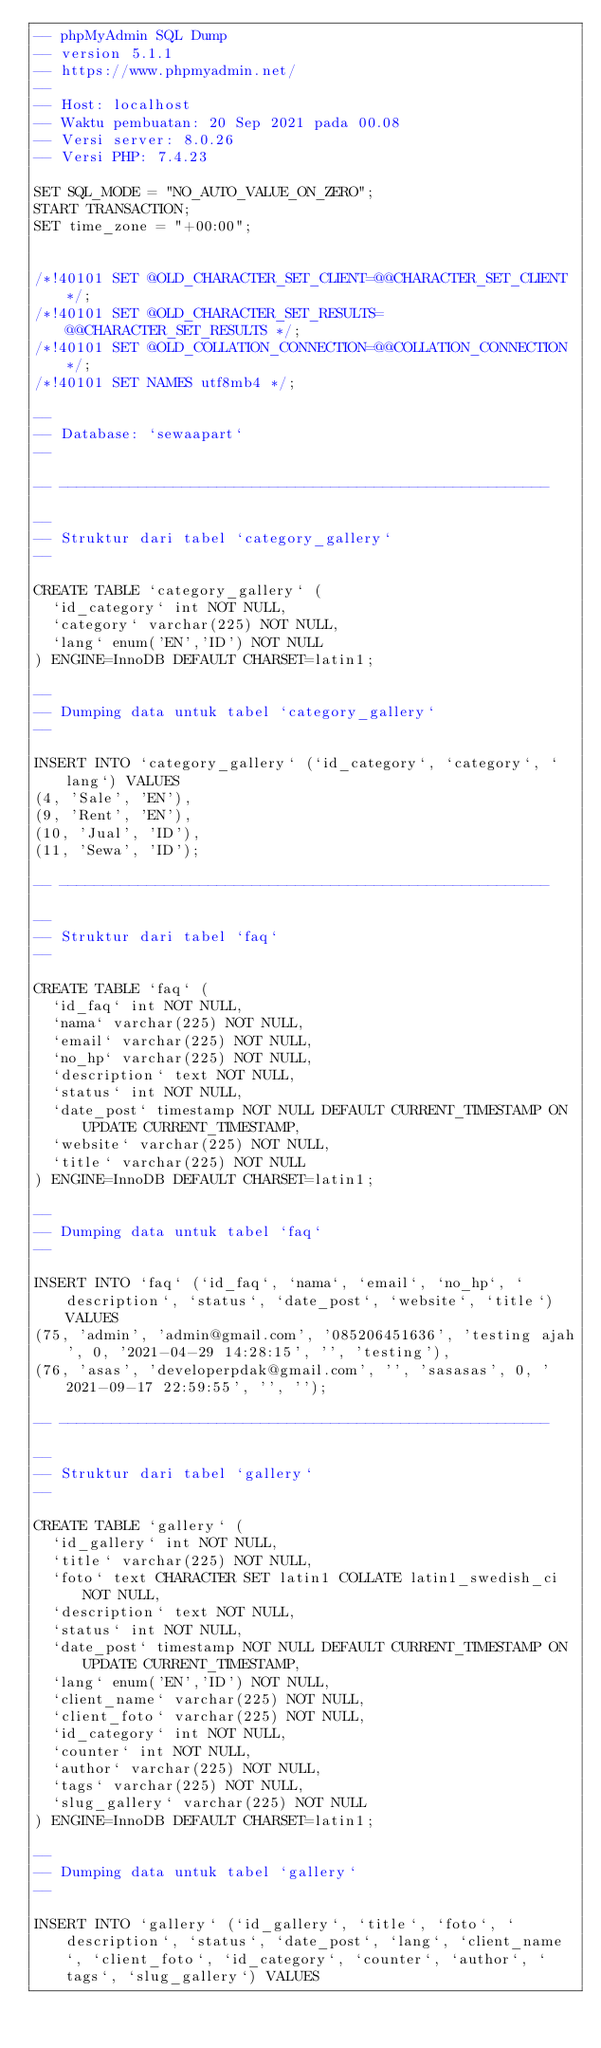Convert code to text. <code><loc_0><loc_0><loc_500><loc_500><_SQL_>-- phpMyAdmin SQL Dump
-- version 5.1.1
-- https://www.phpmyadmin.net/
--
-- Host: localhost
-- Waktu pembuatan: 20 Sep 2021 pada 00.08
-- Versi server: 8.0.26
-- Versi PHP: 7.4.23

SET SQL_MODE = "NO_AUTO_VALUE_ON_ZERO";
START TRANSACTION;
SET time_zone = "+00:00";


/*!40101 SET @OLD_CHARACTER_SET_CLIENT=@@CHARACTER_SET_CLIENT */;
/*!40101 SET @OLD_CHARACTER_SET_RESULTS=@@CHARACTER_SET_RESULTS */;
/*!40101 SET @OLD_COLLATION_CONNECTION=@@COLLATION_CONNECTION */;
/*!40101 SET NAMES utf8mb4 */;

--
-- Database: `sewaapart`
--

-- --------------------------------------------------------

--
-- Struktur dari tabel `category_gallery`
--

CREATE TABLE `category_gallery` (
  `id_category` int NOT NULL,
  `category` varchar(225) NOT NULL,
  `lang` enum('EN','ID') NOT NULL
) ENGINE=InnoDB DEFAULT CHARSET=latin1;

--
-- Dumping data untuk tabel `category_gallery`
--

INSERT INTO `category_gallery` (`id_category`, `category`, `lang`) VALUES
(4, 'Sale', 'EN'),
(9, 'Rent', 'EN'),
(10, 'Jual', 'ID'),
(11, 'Sewa', 'ID');

-- --------------------------------------------------------

--
-- Struktur dari tabel `faq`
--

CREATE TABLE `faq` (
  `id_faq` int NOT NULL,
  `nama` varchar(225) NOT NULL,
  `email` varchar(225) NOT NULL,
  `no_hp` varchar(225) NOT NULL,
  `description` text NOT NULL,
  `status` int NOT NULL,
  `date_post` timestamp NOT NULL DEFAULT CURRENT_TIMESTAMP ON UPDATE CURRENT_TIMESTAMP,
  `website` varchar(225) NOT NULL,
  `title` varchar(225) NOT NULL
) ENGINE=InnoDB DEFAULT CHARSET=latin1;

--
-- Dumping data untuk tabel `faq`
--

INSERT INTO `faq` (`id_faq`, `nama`, `email`, `no_hp`, `description`, `status`, `date_post`, `website`, `title`) VALUES
(75, 'admin', 'admin@gmail.com', '085206451636', 'testing ajah', 0, '2021-04-29 14:28:15', '', 'testing'),
(76, 'asas', 'developerpdak@gmail.com', '', 'sasasas', 0, '2021-09-17 22:59:55', '', '');

-- --------------------------------------------------------

--
-- Struktur dari tabel `gallery`
--

CREATE TABLE `gallery` (
  `id_gallery` int NOT NULL,
  `title` varchar(225) NOT NULL,
  `foto` text CHARACTER SET latin1 COLLATE latin1_swedish_ci NOT NULL,
  `description` text NOT NULL,
  `status` int NOT NULL,
  `date_post` timestamp NOT NULL DEFAULT CURRENT_TIMESTAMP ON UPDATE CURRENT_TIMESTAMP,
  `lang` enum('EN','ID') NOT NULL,
  `client_name` varchar(225) NOT NULL,
  `client_foto` varchar(225) NOT NULL,
  `id_category` int NOT NULL,
  `counter` int NOT NULL,
  `author` varchar(225) NOT NULL,
  `tags` varchar(225) NOT NULL,
  `slug_gallery` varchar(225) NOT NULL
) ENGINE=InnoDB DEFAULT CHARSET=latin1;

--
-- Dumping data untuk tabel `gallery`
--

INSERT INTO `gallery` (`id_gallery`, `title`, `foto`, `description`, `status`, `date_post`, `lang`, `client_name`, `client_foto`, `id_category`, `counter`, `author`, `tags`, `slug_gallery`) VALUES</code> 